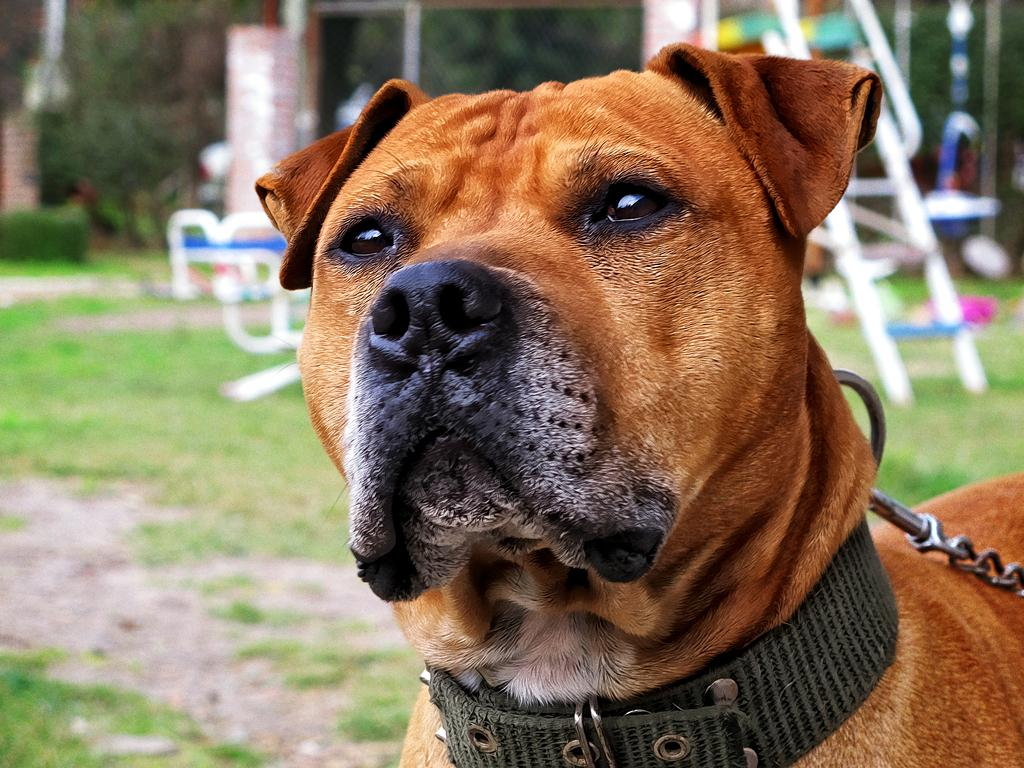What type of animal can be seen in the image, even though it appears to be partially cut off? There is a dog in the image, although it appears to be partially cut off or "truncated." What other elements are present in the image besides the dog? There are plants, the ground, playground equipment, and other objects visible in the image. Can you describe the background of the image? The background of the image is blurred. What type of lace is being used to decorate the dog's collar in the image? There is no lace visible in the image, and the dog's collar is not mentioned in the provided facts. What is the cause of death for the dog in the image? There is no indication of the dog's death in the image or the provided facts. 